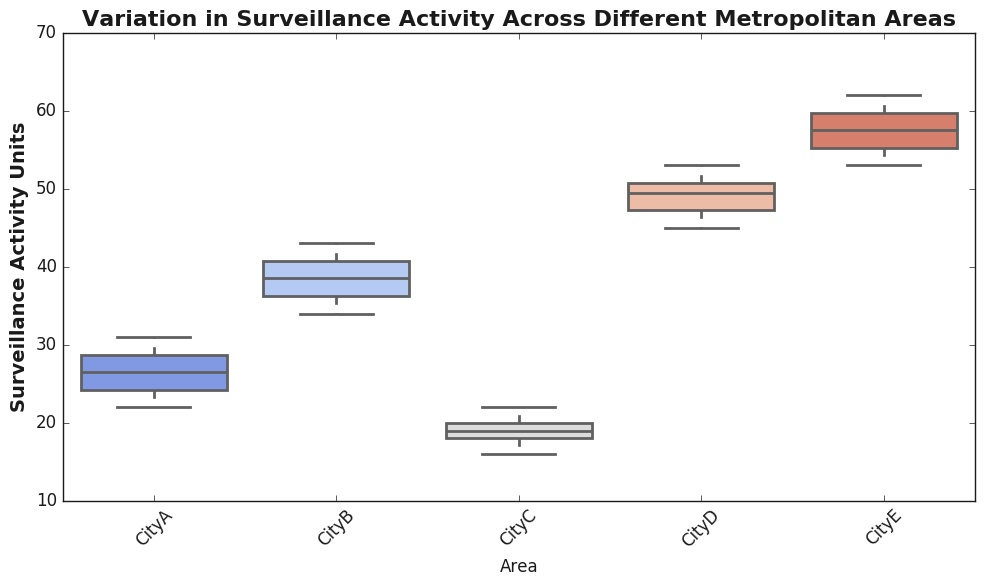What is the median surveillance activity in CityB? From the box plot, the median is indicated by the line inside the box for CityB.
Answer: 38.5 Which city has the highest range of surveillance activity? The range is the difference between the maximum and minimum values. CityE has the highest range because the whiskers extending from the box are the longest.
Answer: CityE Is the variation in surveillance activity for CityD larger or smaller than for CityA? The length of the box represents the interquartile range (IQR), which is a measure of variation. The box for CityD is larger compared to CityA, indicating greater variation.
Answer: Larger Which city has the least median surveillance activity? The median for each city is shown as the line in the middle of the box. CityC has the lowest median value.
Answer: CityC What are the 1st and 3rd quartiles for CityA's surveillance activity? The ends of the box represent the 1st quartile (Q1) and the 3rd quartile (Q3). For CityA, the bottom of the box is around 24.5 (Q1) and the top of the box is around 29.5 (Q3).
Answer: Q1: 24.5, Q3: 29.5 How does the median surveillance activity of CityE compare to that of CityC? By comparing the lines inside the boxes of CityE and CityC, CityE's median is higher.
Answer: Higher Which city has the most outliers in the surveillance activity data? Outliers are identified by points outside the whiskers. CityE has the most outliers as it has points above the upper whisker.
Answer: CityE Is the surveillance activity data for CityC skewed, and if so, in which direction? Skewness can be inferred by comparing the median line position and the whiskers. For CityC, the median is closer to the upper quartile with longer lower whiskers, indicating a left skew.
Answer: Left What is the interquartile range (IQR) for CityD's surveillance activity? The IQR is the difference between the 3rd quartile and the 1st quartile. For CityD, it is approximately 51 - 47 = 4.
Answer: 4 Compare the surveillance activity variability between CityA and CityB. Variability is indicated by the length of the box representing the IQR. CityB has a larger box (IQR) compared to CityA, indicating more variability.
Answer: CityB has more variability 